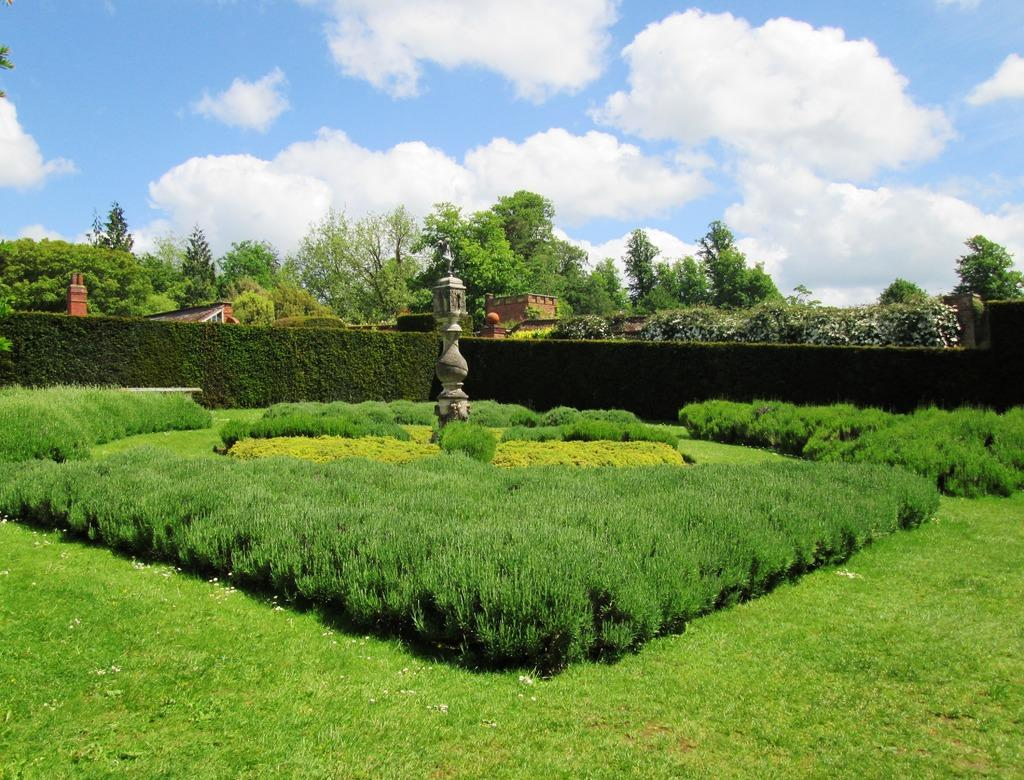What type of vegetation can be seen in the image? There is grass, plants, and trees in the image. What type of structures are present in the image? There are buildings in the image. What is the appearance of the wall in the image? There is a creeper wall in the image. What can be seen in the sky in the image? The sky is visible in the image, and there are clouds in the sky. Can you see a cat playing in the wilderness in the image? There is no cat or wilderness present in the image. 